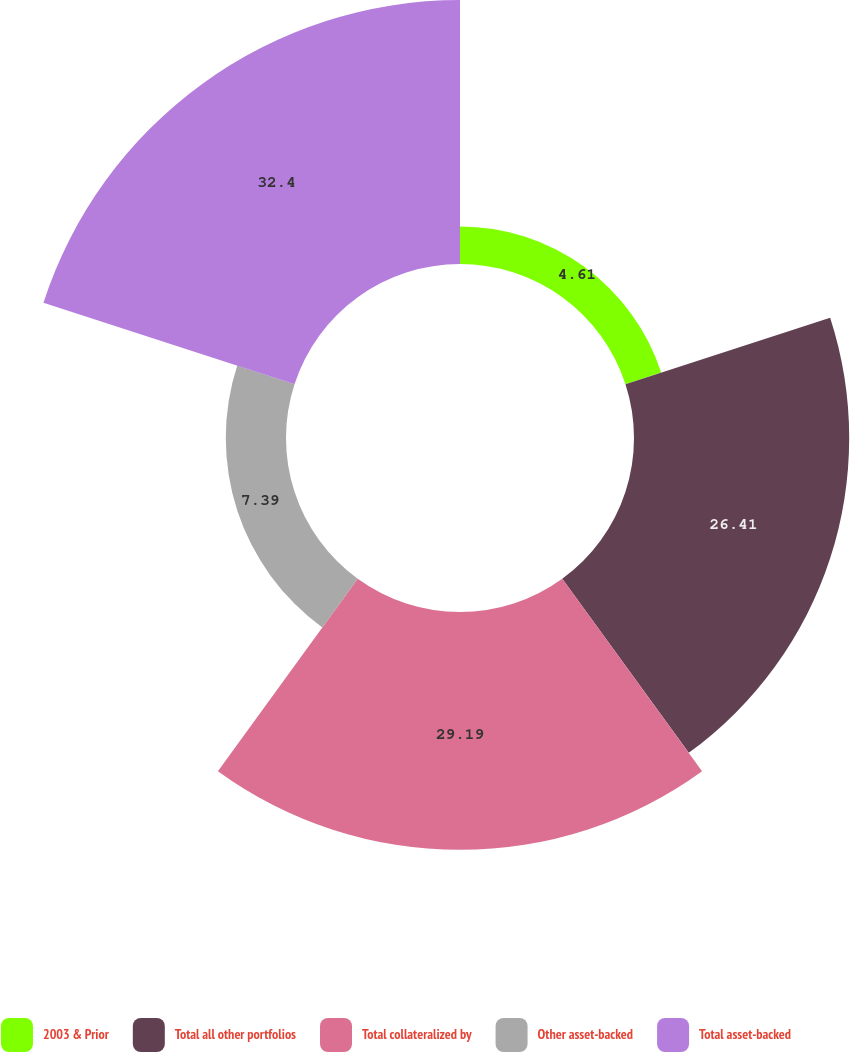<chart> <loc_0><loc_0><loc_500><loc_500><pie_chart><fcel>2003 & Prior<fcel>Total all other portfolios<fcel>Total collateralized by<fcel>Other asset-backed<fcel>Total asset-backed<nl><fcel>4.61%<fcel>26.41%<fcel>29.19%<fcel>7.39%<fcel>32.4%<nl></chart> 